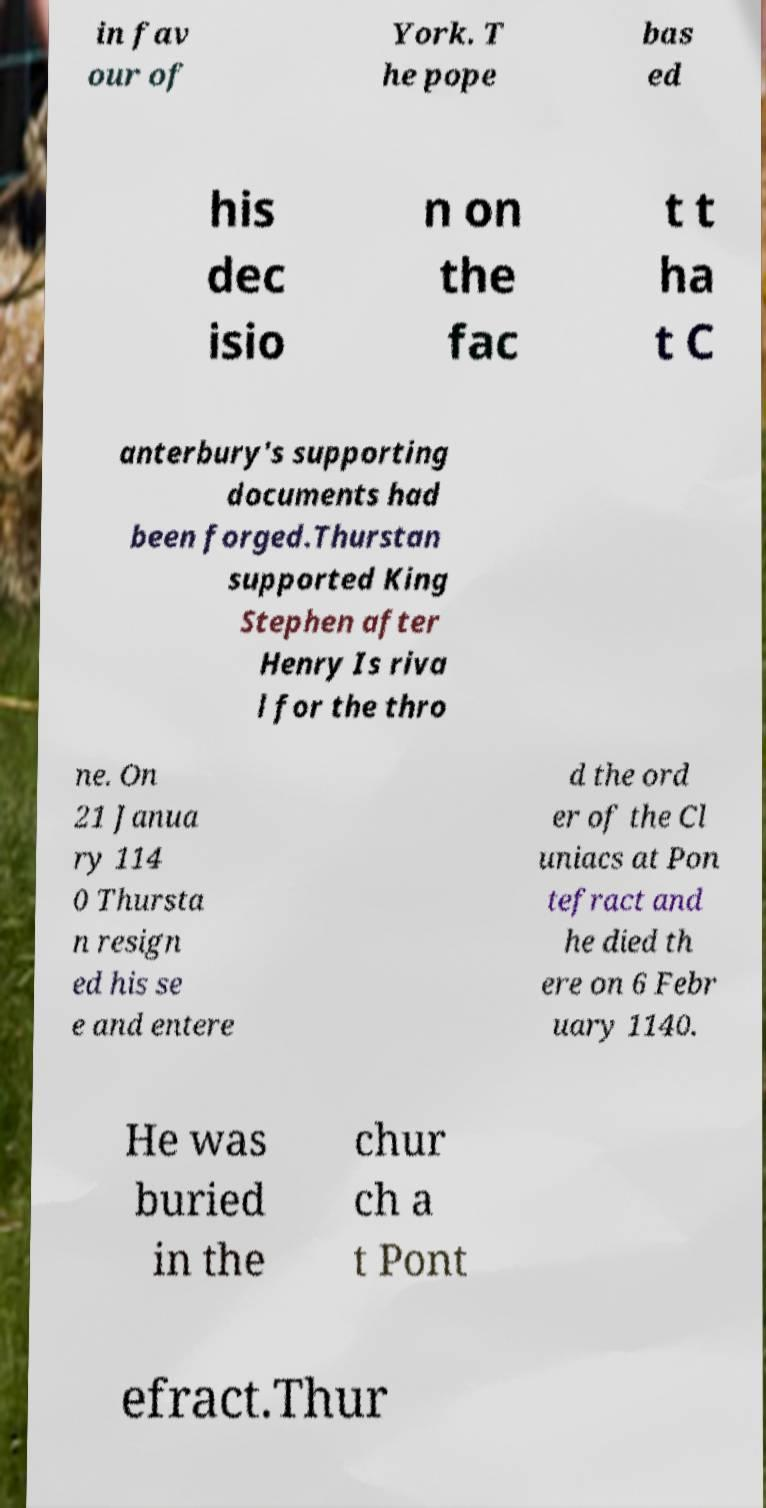Can you accurately transcribe the text from the provided image for me? in fav our of York. T he pope bas ed his dec isio n on the fac t t ha t C anterbury's supporting documents had been forged.Thurstan supported King Stephen after Henry Is riva l for the thro ne. On 21 Janua ry 114 0 Thursta n resign ed his se e and entere d the ord er of the Cl uniacs at Pon tefract and he died th ere on 6 Febr uary 1140. He was buried in the chur ch a t Pont efract.Thur 